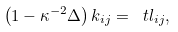Convert formula to latex. <formula><loc_0><loc_0><loc_500><loc_500>\left ( 1 - \kappa ^ { - 2 } \Delta \right ) k _ { i j } = \ t l _ { i j } ,</formula> 